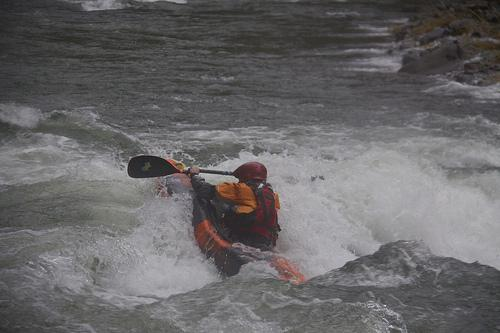Question: who is in the boat?
Choices:
A. A dog.
B. A man.
C. A woman.
D. A person.
Answer with the letter. Answer: D Question: where is the boat?
Choices:
A. Near the wall.
B. In the water.
C. In the lake.
D. Near the rocks.
Answer with the letter. Answer: B Question: what is the person doing?
Choices:
A. Boating.
B. Fishing.
C. Rafting.
D. Swimming.
Answer with the letter. Answer: C Question: how many rafts are shown?
Choices:
A. 12.
B. 1.
C. 13.
D. 5.
Answer with the letter. Answer: B Question: what color is the helmet?
Choices:
A. Red.
B. Teal.
C. Purple.
D. Neon.
Answer with the letter. Answer: A 